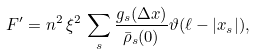<formula> <loc_0><loc_0><loc_500><loc_500>F ^ { \prime } = n ^ { 2 } \, \xi ^ { 2 } \, \sum _ { s } \frac { g _ { s } ( \Delta x ) } { \bar { \rho } _ { s } ( 0 ) } \vartheta ( \ell - | x _ { s } | ) ,</formula> 